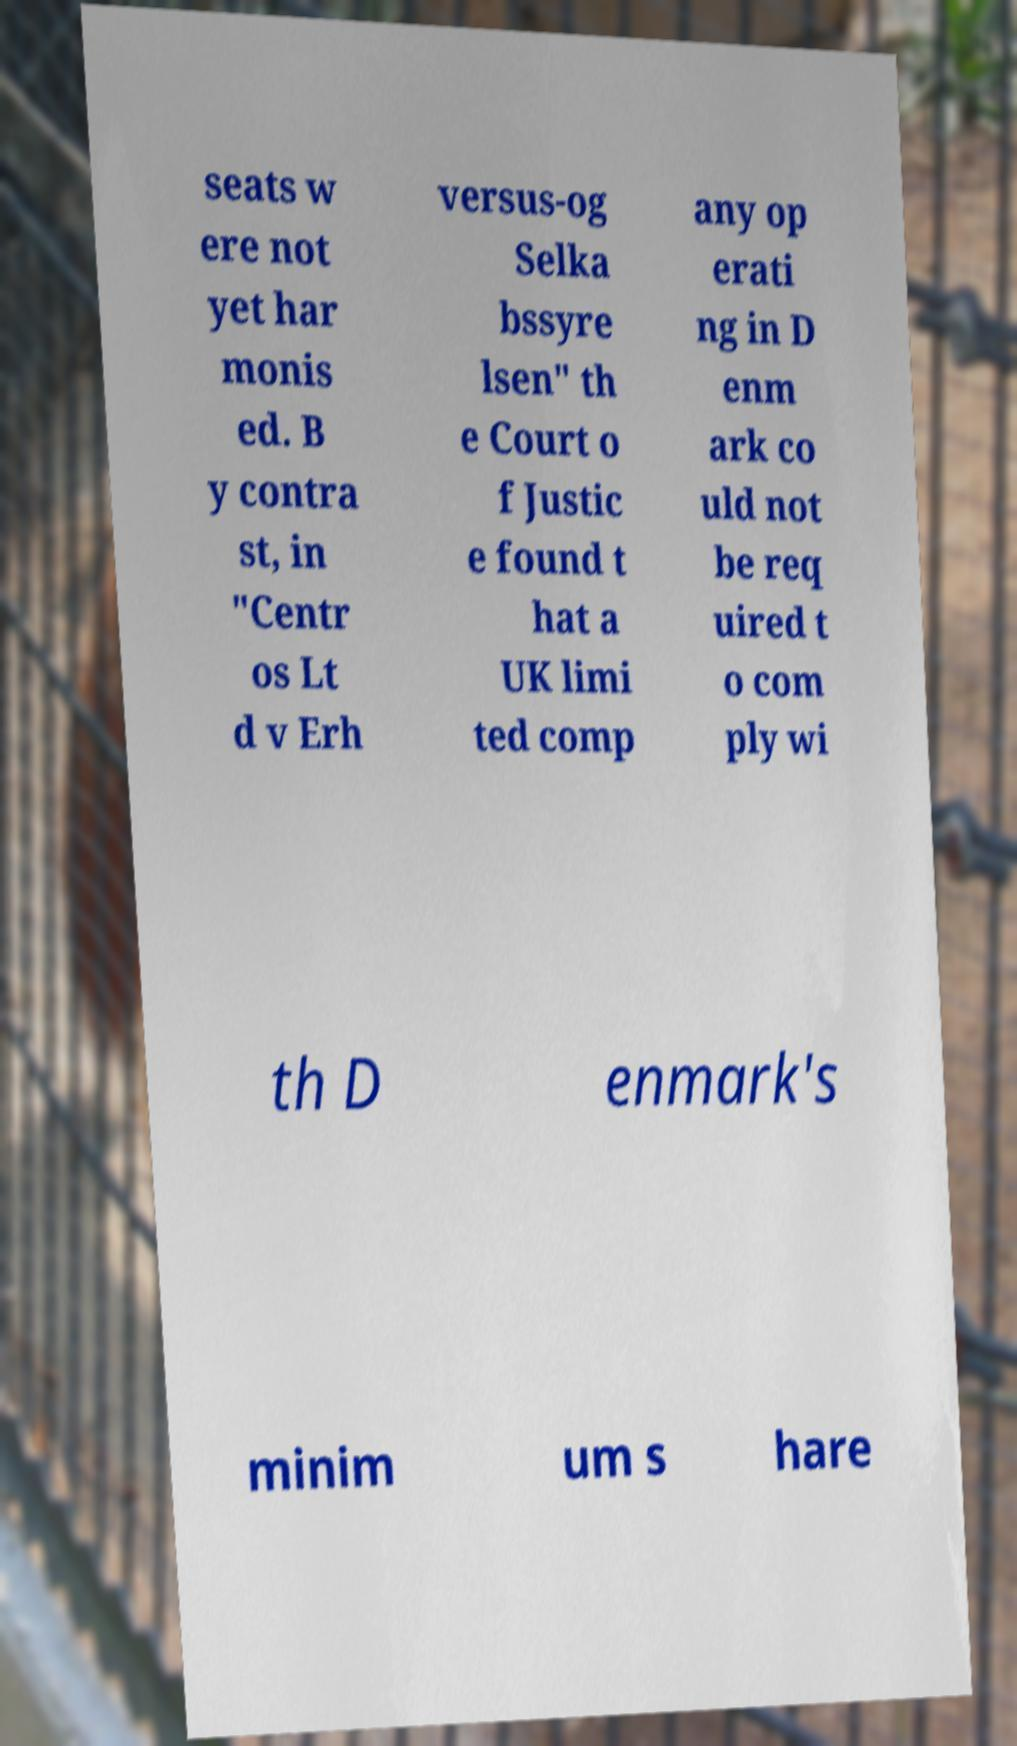What messages or text are displayed in this image? I need them in a readable, typed format. seats w ere not yet har monis ed. B y contra st, in "Centr os Lt d v Erh versus-og Selka bssyre lsen" th e Court o f Justic e found t hat a UK limi ted comp any op erati ng in D enm ark co uld not be req uired t o com ply wi th D enmark's minim um s hare 